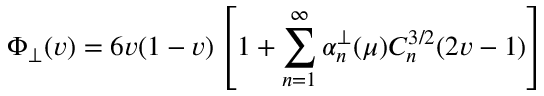Convert formula to latex. <formula><loc_0><loc_0><loc_500><loc_500>\Phi _ { \perp } ( v ) = 6 v ( 1 - v ) \left [ 1 + \sum _ { n = 1 } ^ { \infty } \alpha _ { n } ^ { \perp } ( \mu ) C _ { n } ^ { 3 / 2 } ( 2 v - 1 ) \right ]</formula> 